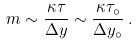<formula> <loc_0><loc_0><loc_500><loc_500>m \sim \frac { \kappa \tau } { \Delta y } \sim \frac { \kappa \tau _ { \circ } } { \Delta y _ { \circ } } \, .</formula> 